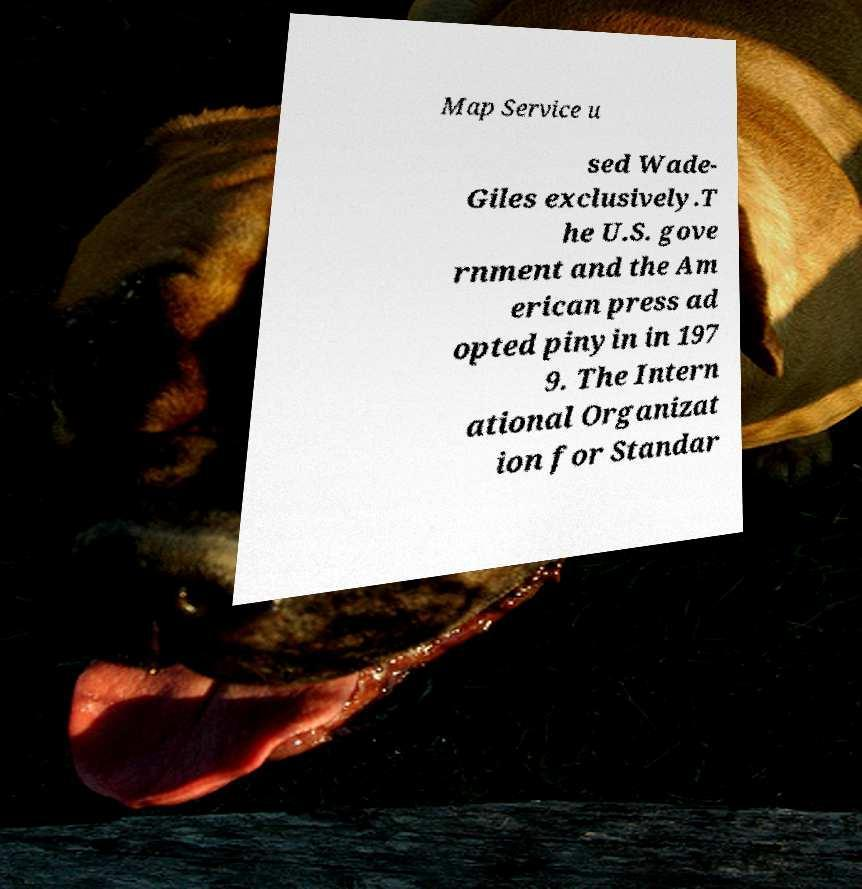Please identify and transcribe the text found in this image. Map Service u sed Wade- Giles exclusively.T he U.S. gove rnment and the Am erican press ad opted pinyin in 197 9. The Intern ational Organizat ion for Standar 